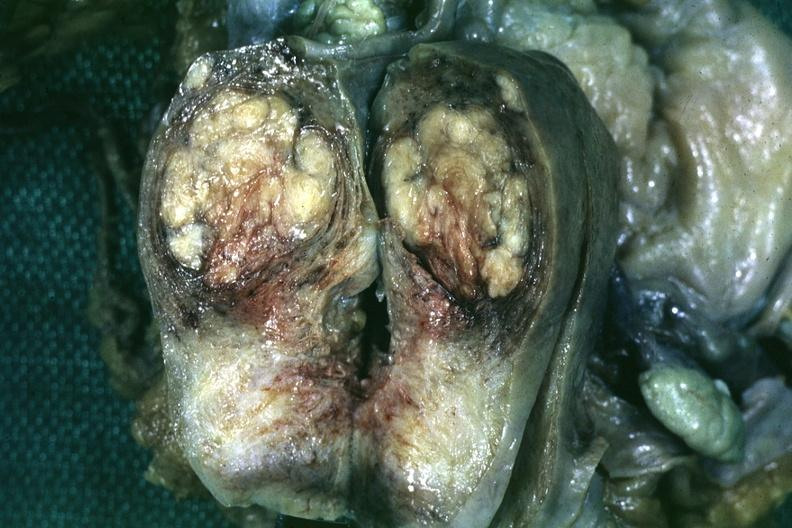what is present?
Answer the question using a single word or phrase. Leiomyoma 